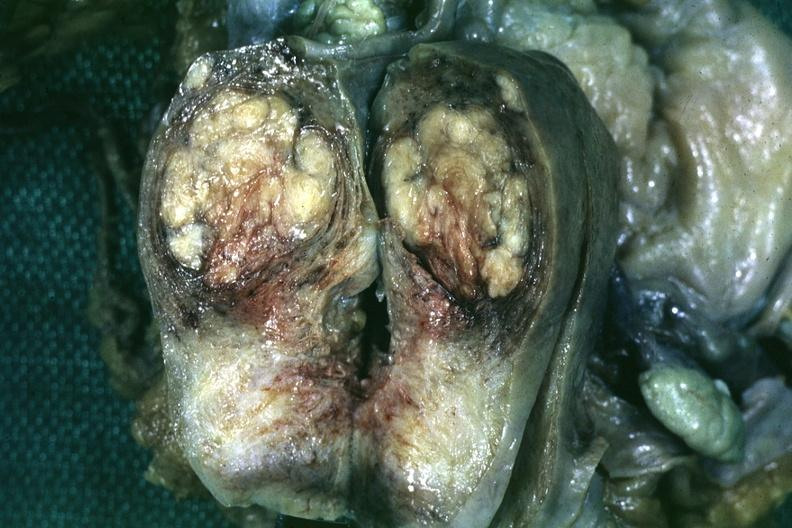what is present?
Answer the question using a single word or phrase. Leiomyoma 